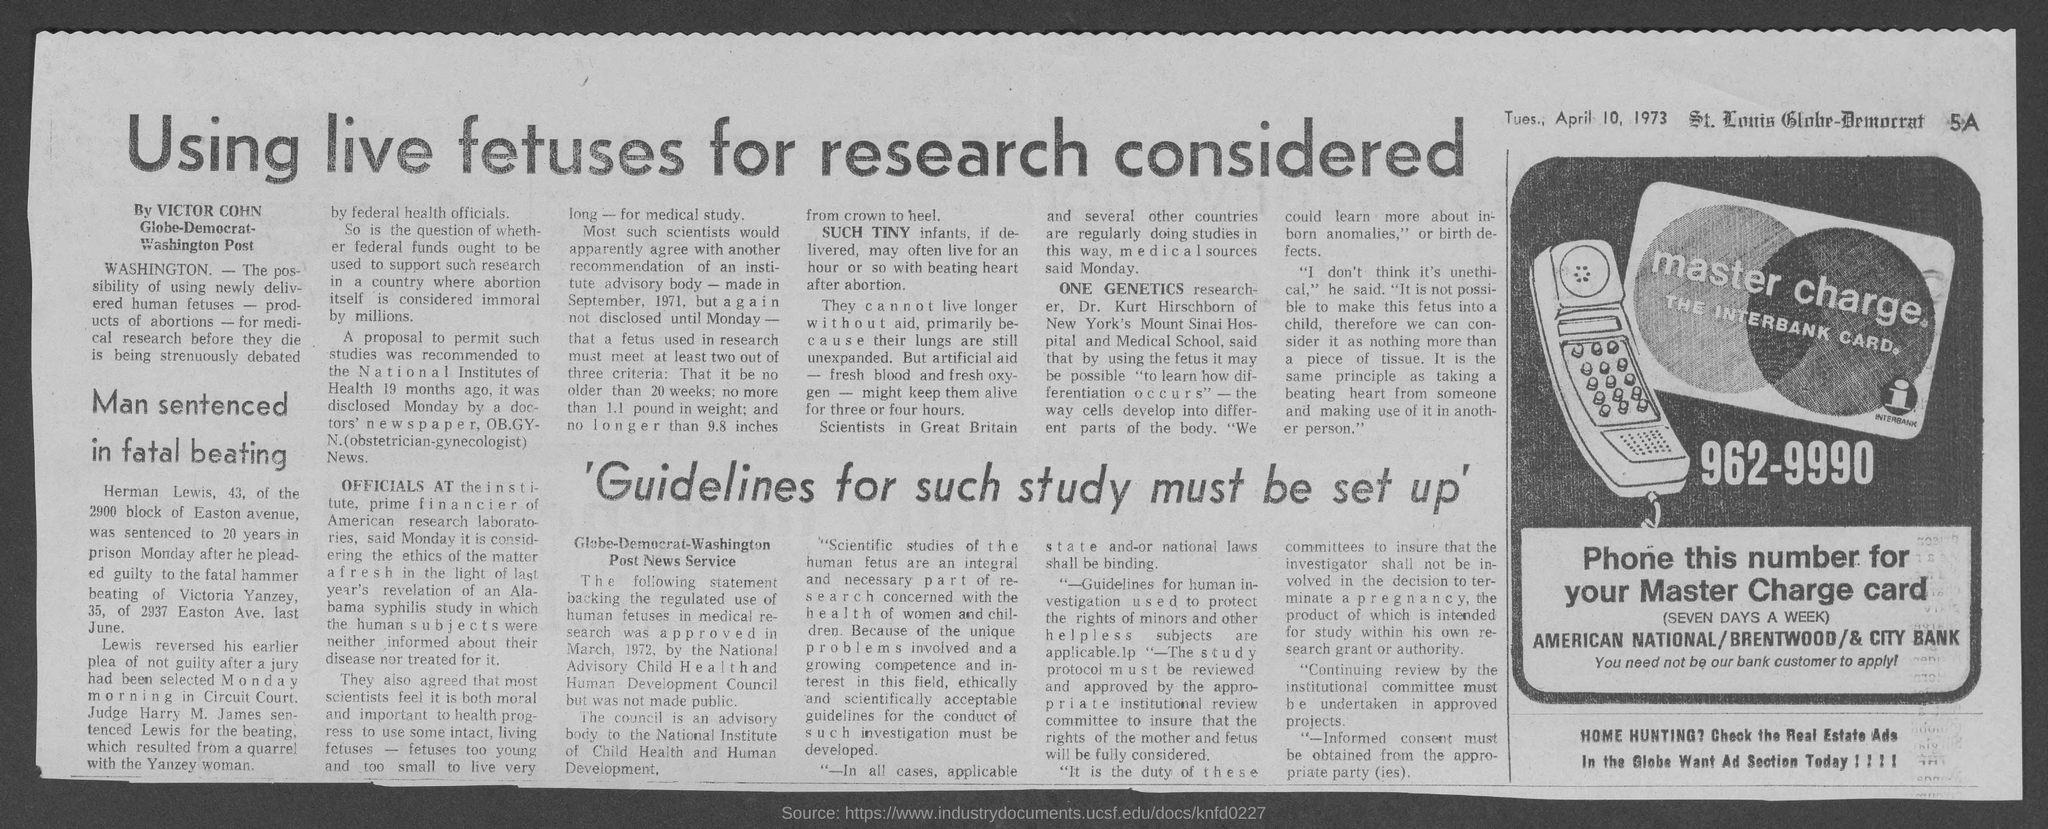Give some essential details in this illustration. The article was written by Victor Cohn. The phone number is 962-9990. The date mentioned in the document is Tuesday, April 10, 1973. 